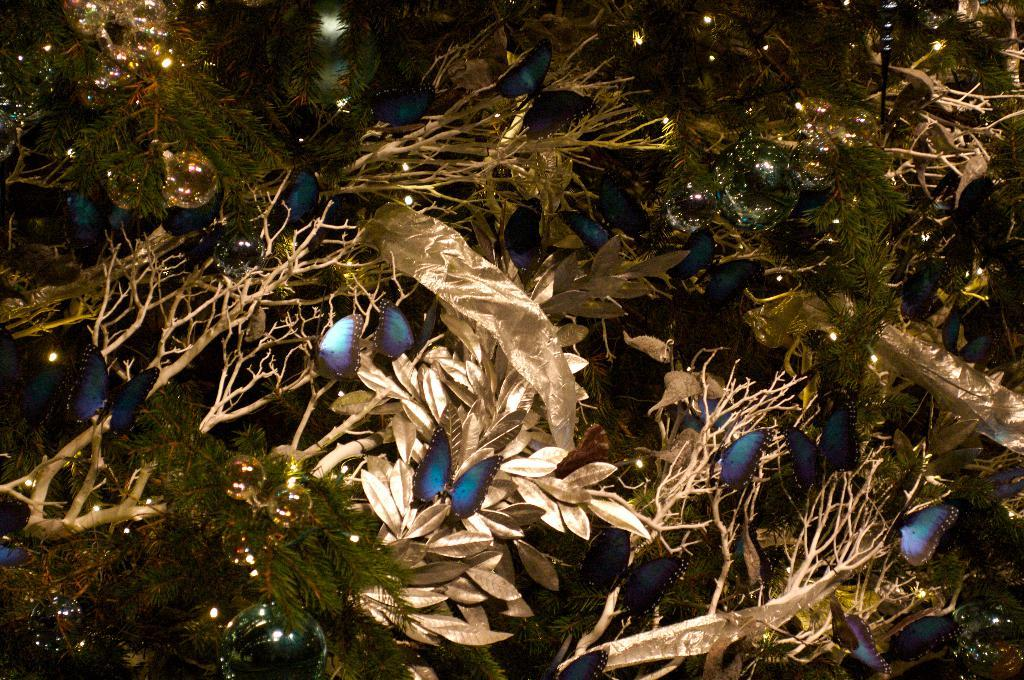What type of natural elements can be seen in the picture? There are leaves in the picture. What type of insects can be seen in the picture? There are butterflies in the picture. What type of artificial elements can be seen in the picture? There are lights in the picture. What type of food is being prepared in the picture? There is no food present in the image; it features leaves, butterflies, and lights. Can you tell me how many basketballs are visible in the picture? There are no basketballs present in the image. 